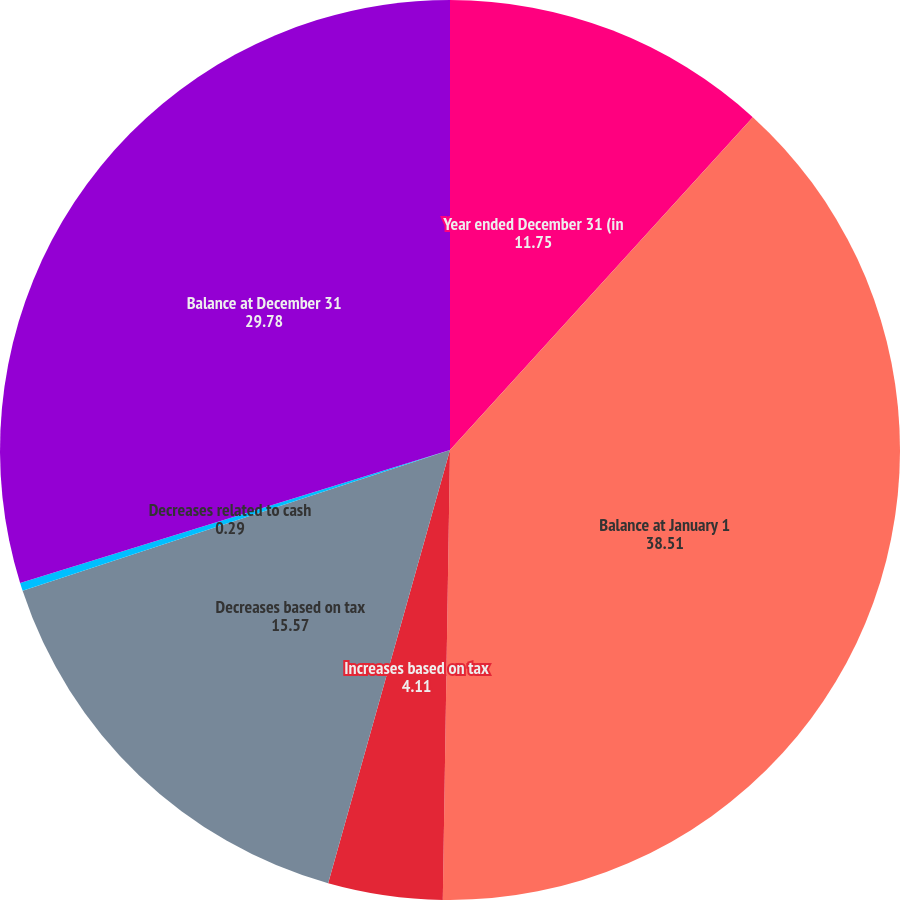Convert chart to OTSL. <chart><loc_0><loc_0><loc_500><loc_500><pie_chart><fcel>Year ended December 31 (in<fcel>Balance at January 1<fcel>Increases based on tax<fcel>Decreases based on tax<fcel>Decreases related to cash<fcel>Balance at December 31<nl><fcel>11.75%<fcel>38.51%<fcel>4.11%<fcel>15.57%<fcel>0.29%<fcel>29.78%<nl></chart> 